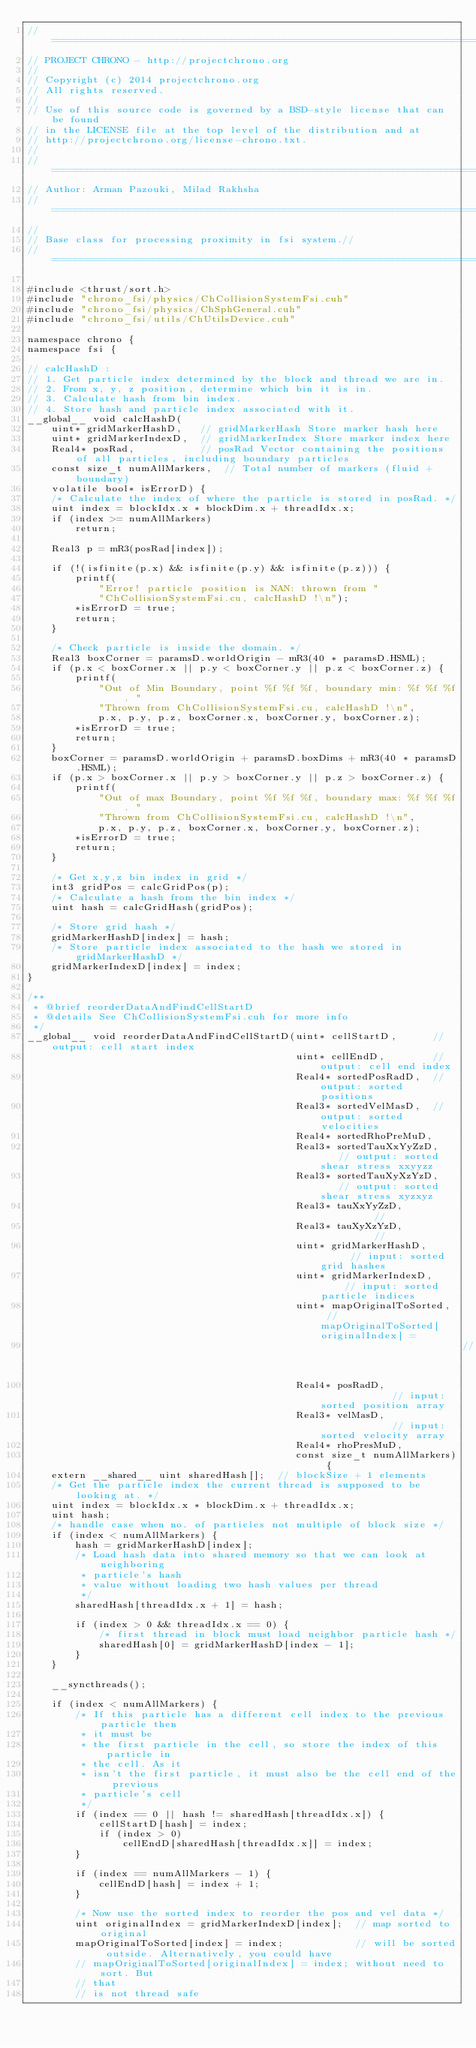<code> <loc_0><loc_0><loc_500><loc_500><_Cuda_>// =============================================================================
// PROJECT CHRONO - http://projectchrono.org
//
// Copyright (c) 2014 projectchrono.org
// All rights reserved.
//
// Use of this source code is governed by a BSD-style license that can be found
// in the LICENSE file at the top level of the distribution and at
// http://projectchrono.org/license-chrono.txt.
//
// =============================================================================
// Author: Arman Pazouki, Milad Rakhsha
// =============================================================================
//
// Base class for processing proximity in fsi system.//
// =============================================================================

#include <thrust/sort.h>
#include "chrono_fsi/physics/ChCollisionSystemFsi.cuh"
#include "chrono_fsi/physics/ChSphGeneral.cuh"
#include "chrono_fsi/utils/ChUtilsDevice.cuh"

namespace chrono {
namespace fsi {

// calcHashD :
// 1. Get particle index determined by the block and thread we are in.
// 2. From x, y, z position, determine which bin it is in.
// 3. Calculate hash from bin index.
// 4. Store hash and particle index associated with it.
__global__ void calcHashD(
    uint* gridMarkerHashD,   // gridMarkerHash Store marker hash here
    uint* gridMarkerIndexD,  // gridMarkerIndex Store marker index here
    Real4* posRad,           // posRad Vector containing the positions of all particles, including boundary particles
    const size_t numAllMarkers,  // Total number of markers (fluid + boundary)
    volatile bool* isErrorD) {
    /* Calculate the index of where the particle is stored in posRad. */
    uint index = blockIdx.x * blockDim.x + threadIdx.x;
    if (index >= numAllMarkers)
        return;

    Real3 p = mR3(posRad[index]);

    if (!(isfinite(p.x) && isfinite(p.y) && isfinite(p.z))) {
        printf(
            "Error! particle position is NAN: thrown from "
            "ChCollisionSystemFsi.cu, calcHashD !\n");
        *isErrorD = true;
        return;
    }

    /* Check particle is inside the domain. */
    Real3 boxCorner = paramsD.worldOrigin - mR3(40 * paramsD.HSML);
    if (p.x < boxCorner.x || p.y < boxCorner.y || p.z < boxCorner.z) {
        printf(
            "Out of Min Boundary, point %f %f %f, boundary min: %f %f %f. "
            "Thrown from ChCollisionSystemFsi.cu, calcHashD !\n",
            p.x, p.y, p.z, boxCorner.x, boxCorner.y, boxCorner.z);
        *isErrorD = true;
        return;
    }
    boxCorner = paramsD.worldOrigin + paramsD.boxDims + mR3(40 * paramsD.HSML);
    if (p.x > boxCorner.x || p.y > boxCorner.y || p.z > boxCorner.z) {
        printf(
            "Out of max Boundary, point %f %f %f, boundary max: %f %f %f. "
            "Thrown from ChCollisionSystemFsi.cu, calcHashD !\n",
            p.x, p.y, p.z, boxCorner.x, boxCorner.y, boxCorner.z);
        *isErrorD = true;
        return;
    }

    /* Get x,y,z bin index in grid */
    int3 gridPos = calcGridPos(p);
    /* Calculate a hash from the bin index */
    uint hash = calcGridHash(gridPos);

    /* Store grid hash */
    gridMarkerHashD[index] = hash;
    /* Store particle index associated to the hash we stored in gridMarkerHashD */
    gridMarkerIndexD[index] = index;
}

/**
 * @brief reorderDataAndFindCellStartD
 * @details See ChCollisionSystemFsi.cuh for more info
 */
__global__ void reorderDataAndFindCellStartD(uint* cellStartD,      // output: cell start index
                                             uint* cellEndD,        // output: cell end index
                                             Real4* sortedPosRadD,  // output: sorted positions
                                             Real3* sortedVelMasD,  // output: sorted velocities
                                             Real4* sortedRhoPreMuD,
                                             Real3* sortedTauXxYyZzD,    // output: sorted shear stress xxyyzz
                                             Real3* sortedTauXyXzYzD,    // output: sorted shear stress xyzxyz
                                             Real3* tauXxYyZzD,          // 
                                             Real3* tauXyXzYzD,          // 
                                             uint* gridMarkerHashD,      // input: sorted grid hashes
                                             uint* gridMarkerIndexD,     // input: sorted particle indices
                                             uint* mapOriginalToSorted,  // mapOriginalToSorted[originalIndex] =
                                                                         // originalIndex
                                             Real4* posRadD,             // input: sorted position array
                                             Real3* velMasD,             // input: sorted velocity array
                                             Real4* rhoPresMuD,
                                             const size_t numAllMarkers) {
    extern __shared__ uint sharedHash[];  // blockSize + 1 elements
    /* Get the particle index the current thread is supposed to be looking at. */
    uint index = blockIdx.x * blockDim.x + threadIdx.x;
    uint hash;
    /* handle case when no. of particles not multiple of block size */
    if (index < numAllMarkers) {
        hash = gridMarkerHashD[index];
        /* Load hash data into shared memory so that we can look at neighboring
         * particle's hash
         * value without loading two hash values per thread
         */
        sharedHash[threadIdx.x + 1] = hash;

        if (index > 0 && threadIdx.x == 0) {
            /* first thread in block must load neighbor particle hash */
            sharedHash[0] = gridMarkerHashD[index - 1];
        }
    }

    __syncthreads();

    if (index < numAllMarkers) {
        /* If this particle has a different cell index to the previous particle then
         * it must be
         * the first particle in the cell, so store the index of this particle in
         * the cell. As it
         * isn't the first particle, it must also be the cell end of the previous
         * particle's cell
         */
        if (index == 0 || hash != sharedHash[threadIdx.x]) {
            cellStartD[hash] = index;
            if (index > 0)
                cellEndD[sharedHash[threadIdx.x]] = index;
        }

        if (index == numAllMarkers - 1) {
            cellEndD[hash] = index + 1;
        }

        /* Now use the sorted index to reorder the pos and vel data */
        uint originalIndex = gridMarkerIndexD[index];  // map sorted to original
        mapOriginalToSorted[index] = index;            // will be sorted outside. Alternatively, you could have
        // mapOriginalToSorted[originalIndex] = index; without need to sort. But
        // that
        // is not thread safe</code> 